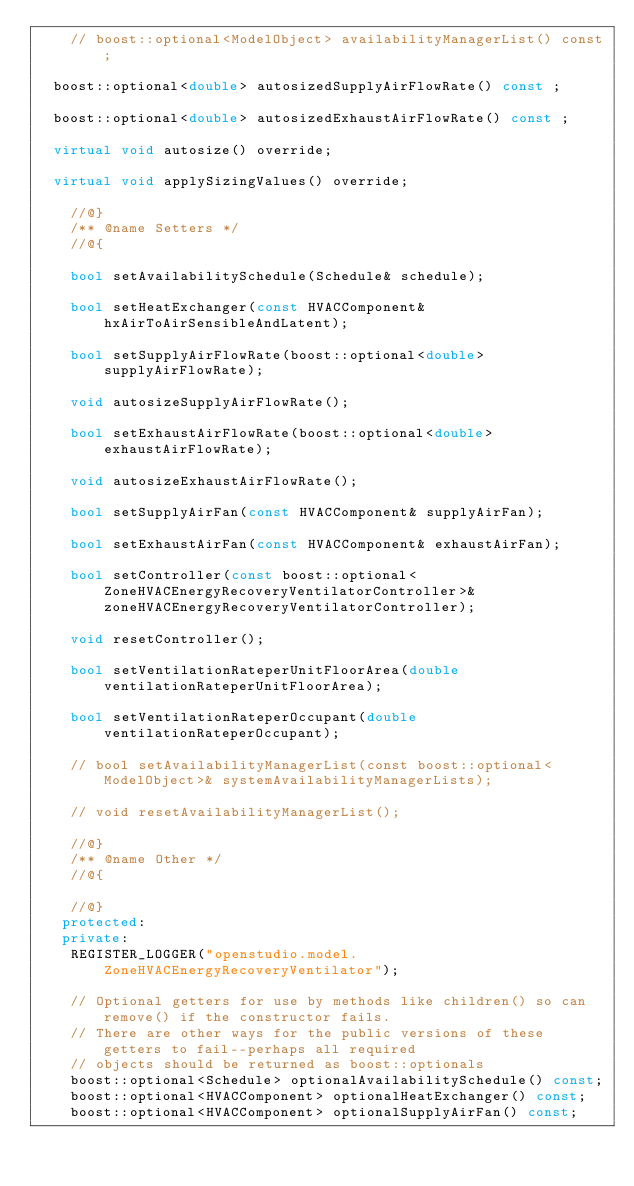Convert code to text. <code><loc_0><loc_0><loc_500><loc_500><_C++_>    // boost::optional<ModelObject> availabilityManagerList() const;

  boost::optional<double> autosizedSupplyAirFlowRate() const ;

  boost::optional<double> autosizedExhaustAirFlowRate() const ;

  virtual void autosize() override;

  virtual void applySizingValues() override;

    //@}
    /** @name Setters */
    //@{

    bool setAvailabilitySchedule(Schedule& schedule);

    bool setHeatExchanger(const HVACComponent& hxAirToAirSensibleAndLatent);

    bool setSupplyAirFlowRate(boost::optional<double> supplyAirFlowRate);

    void autosizeSupplyAirFlowRate();

    bool setExhaustAirFlowRate(boost::optional<double> exhaustAirFlowRate);

    void autosizeExhaustAirFlowRate();

    bool setSupplyAirFan(const HVACComponent& supplyAirFan);

    bool setExhaustAirFan(const HVACComponent& exhaustAirFan);

    bool setController(const boost::optional<ZoneHVACEnergyRecoveryVentilatorController>& zoneHVACEnergyRecoveryVentilatorController);

    void resetController();

    bool setVentilationRateperUnitFloorArea(double ventilationRateperUnitFloorArea);

    bool setVentilationRateperOccupant(double ventilationRateperOccupant);

    // bool setAvailabilityManagerList(const boost::optional<ModelObject>& systemAvailabilityManagerLists);

    // void resetAvailabilityManagerList();

    //@}
    /** @name Other */
    //@{

    //@}
   protected:
   private:
    REGISTER_LOGGER("openstudio.model.ZoneHVACEnergyRecoveryVentilator");

    // Optional getters for use by methods like children() so can remove() if the constructor fails.
    // There are other ways for the public versions of these getters to fail--perhaps all required
    // objects should be returned as boost::optionals
    boost::optional<Schedule> optionalAvailabilitySchedule() const;
    boost::optional<HVACComponent> optionalHeatExchanger() const;
    boost::optional<HVACComponent> optionalSupplyAirFan() const;</code> 